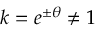Convert formula to latex. <formula><loc_0><loc_0><loc_500><loc_500>k = e ^ { \pm \theta } \neq 1</formula> 